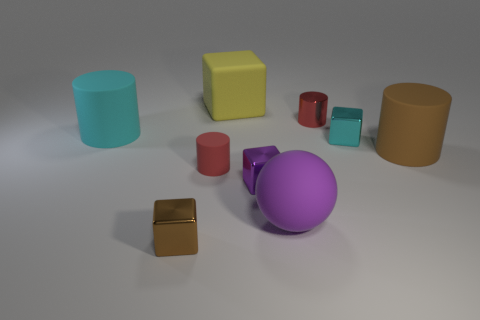Add 1 cylinders. How many objects exist? 10 Subtract all blue cylinders. Subtract all brown cubes. How many cylinders are left? 4 Subtract all cylinders. How many objects are left? 5 Subtract all tiny gray matte spheres. Subtract all tiny objects. How many objects are left? 4 Add 7 big purple rubber objects. How many big purple rubber objects are left? 8 Add 9 small yellow rubber spheres. How many small yellow rubber spheres exist? 9 Subtract 0 red spheres. How many objects are left? 9 